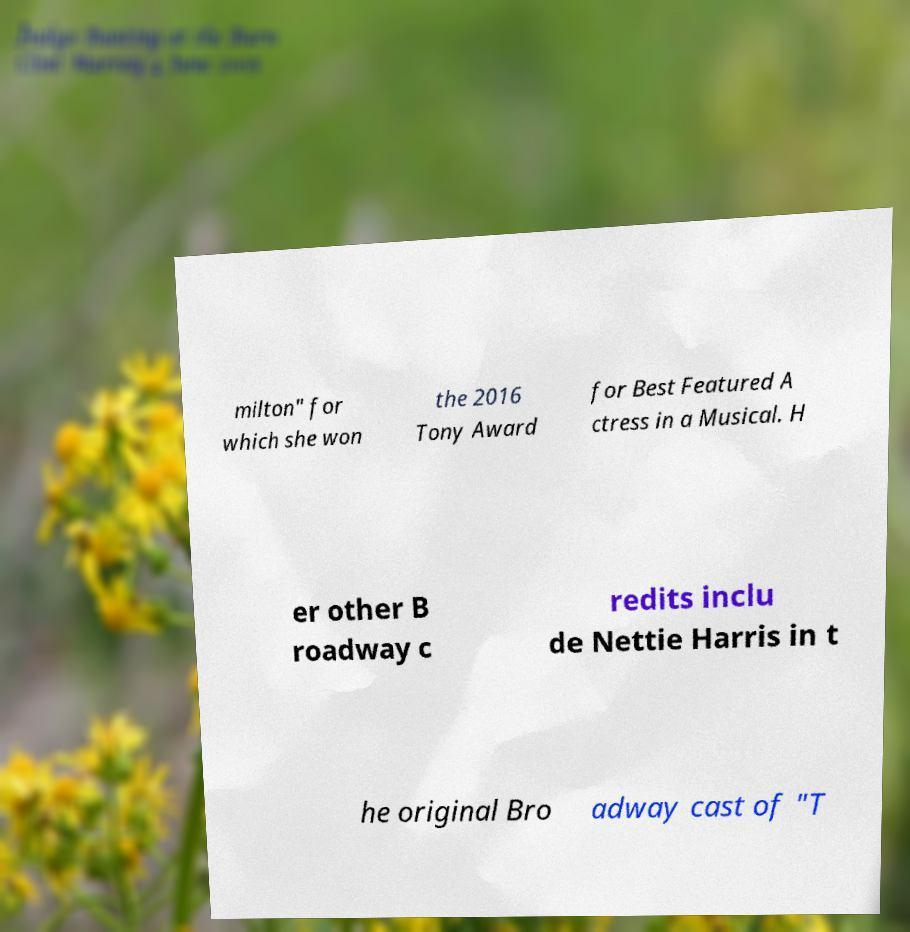For documentation purposes, I need the text within this image transcribed. Could you provide that? milton" for which she won the 2016 Tony Award for Best Featured A ctress in a Musical. H er other B roadway c redits inclu de Nettie Harris in t he original Bro adway cast of "T 